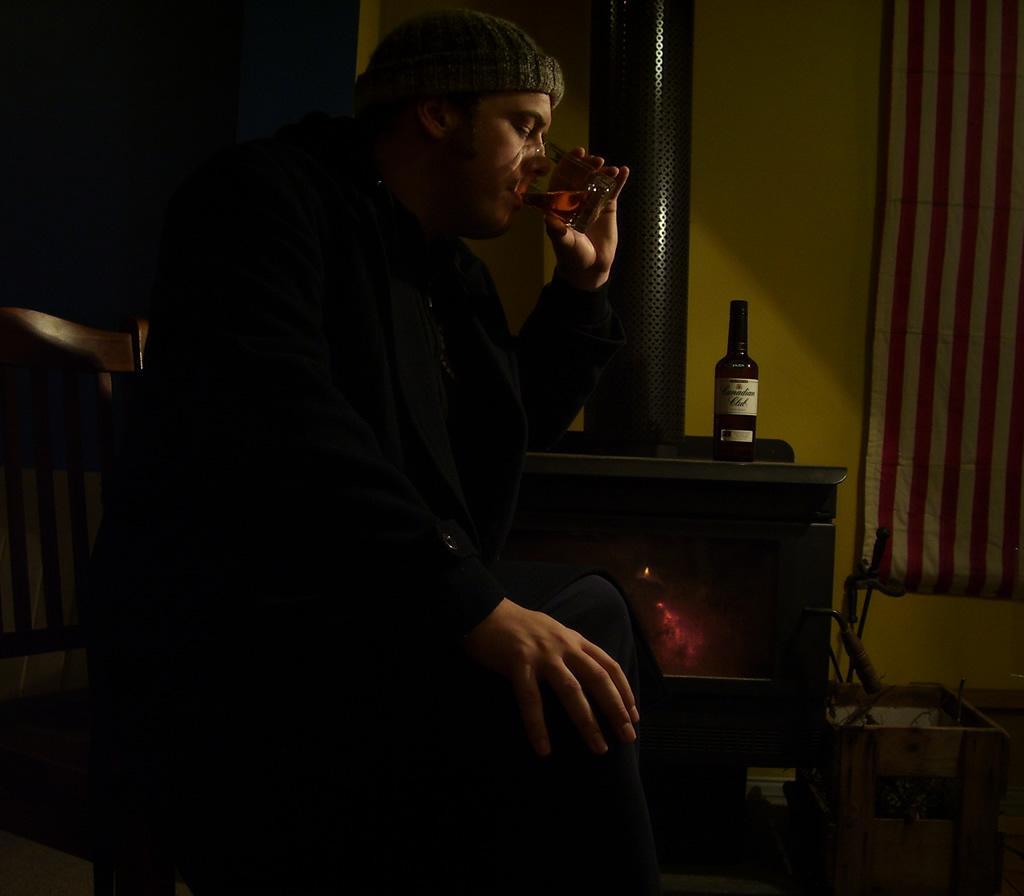Could you give a brief overview of what you see in this image? In this picture we can see a man is sitting on a chair and drinking something, on the right side there is a curtain, we can see a bottle in the middle, in the background we can see a wall and fireplace. 